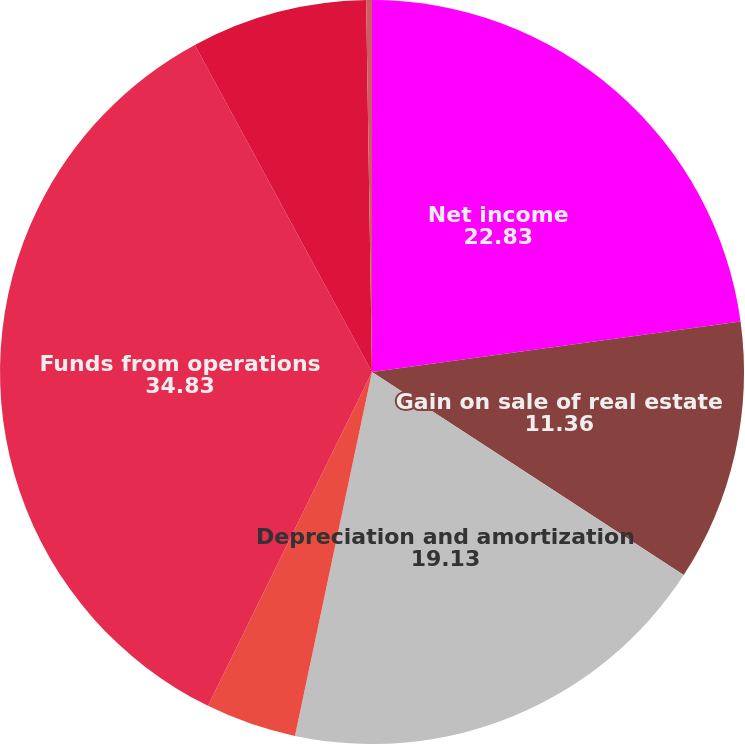<chart> <loc_0><loc_0><loc_500><loc_500><pie_chart><fcel>Net income<fcel>Gain on sale of real estate<fcel>Depreciation and amortization<fcel>Amortization of initial direct<fcel>Funds from operations<fcel>Dividends on preferred stock<fcel>Income attributable to<nl><fcel>22.83%<fcel>11.36%<fcel>19.13%<fcel>3.95%<fcel>34.83%<fcel>7.65%<fcel>0.25%<nl></chart> 